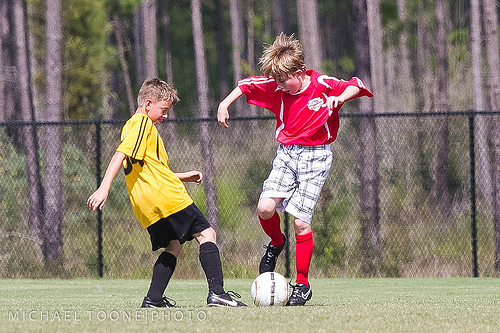<image>
Is there a boy on the foot ball? Yes. Looking at the image, I can see the boy is positioned on top of the foot ball, with the foot ball providing support. Is there a boy on the ball? No. The boy is not positioned on the ball. They may be near each other, but the boy is not supported by or resting on top of the ball. 